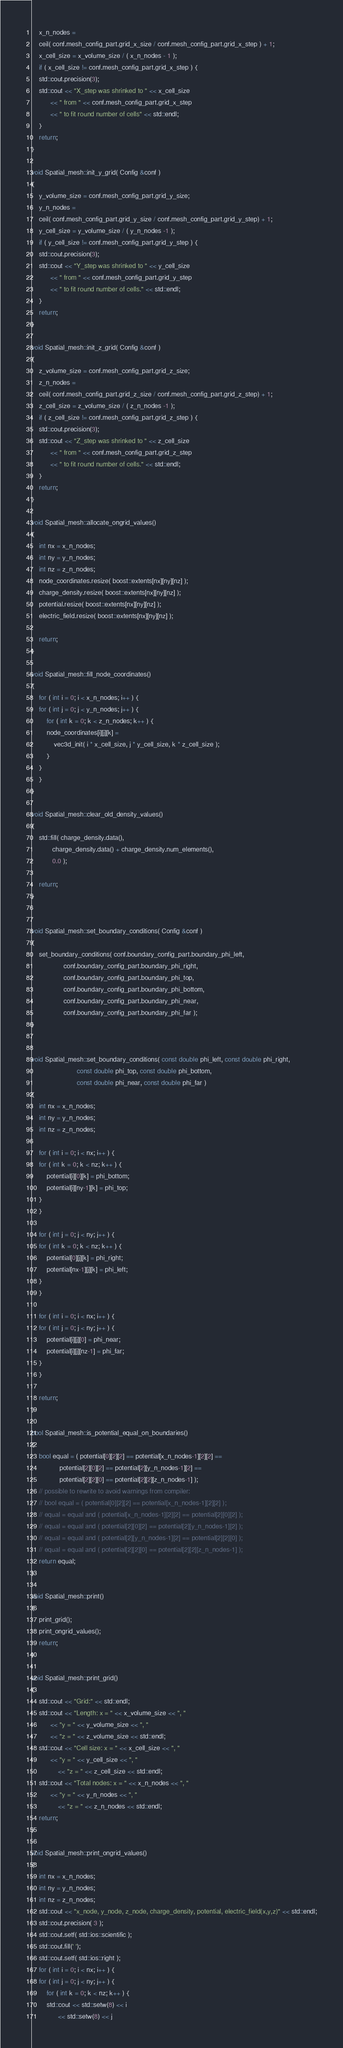Convert code to text. <code><loc_0><loc_0><loc_500><loc_500><_C++_>    x_n_nodes = 
	ceil( conf.mesh_config_part.grid_x_size / conf.mesh_config_part.grid_x_step ) + 1;
    x_cell_size = x_volume_size / ( x_n_nodes - 1 );
    if ( x_cell_size != conf.mesh_config_part.grid_x_step ) {
	std::cout.precision(3);
	std::cout << "X_step was shrinked to " << x_cell_size 
		  << " from " << conf.mesh_config_part.grid_x_step 
		  << " to fit round number of cells" << std::endl;
    }    
    return;
}

void Spatial_mesh::init_y_grid( Config &conf )
{
    y_volume_size = conf.mesh_config_part.grid_y_size;
    y_n_nodes = 
	ceil( conf.mesh_config_part.grid_y_size / conf.mesh_config_part.grid_y_step) + 1;
    y_cell_size = y_volume_size / ( y_n_nodes -1 );
    if ( y_cell_size != conf.mesh_config_part.grid_y_step ) {
	std::cout.precision(3);
	std::cout << "Y_step was shrinked to " << y_cell_size 
		  << " from " << conf.mesh_config_part.grid_y_step 
		  << " to fit round number of cells." << std::endl;
    }    
    return;
}

void Spatial_mesh::init_z_grid( Config &conf )
{
    z_volume_size = conf.mesh_config_part.grid_z_size;
    z_n_nodes = 
	ceil( conf.mesh_config_part.grid_z_size / conf.mesh_config_part.grid_z_step) + 1;
    z_cell_size = z_volume_size / ( z_n_nodes -1 );
    if ( z_cell_size != conf.mesh_config_part.grid_z_step ) {
	std::cout.precision(3);
	std::cout << "Z_step was shrinked to " << z_cell_size 
		  << " from " << conf.mesh_config_part.grid_z_step 
		  << " to fit round number of cells." << std::endl;
    }    
    return;
}

void Spatial_mesh::allocate_ongrid_values()
{
    int nx = x_n_nodes;
    int ny = y_n_nodes;
    int nz = z_n_nodes;
    node_coordinates.resize( boost::extents[nx][ny][nz] );
    charge_density.resize( boost::extents[nx][ny][nz] );
    potential.resize( boost::extents[nx][ny][nz] );
    electric_field.resize( boost::extents[nx][ny][nz] );

    return;
}

void Spatial_mesh::fill_node_coordinates()
{
    for ( int i = 0; i < x_n_nodes; i++ ) {
	for ( int j = 0; j < y_n_nodes; j++ ) {
	    for ( int k = 0; k < z_n_nodes; k++ ) {
		node_coordinates[i][j][k] =
		    vec3d_init( i * x_cell_size, j * y_cell_size, k * z_cell_size );
	    }
	}
    }
}

void Spatial_mesh::clear_old_density_values()
{
    std::fill( charge_density.data(),
	       charge_density.data() + charge_density.num_elements(),
	       0.0 );

    return;
}


void Spatial_mesh::set_boundary_conditions( Config &conf )
{
    set_boundary_conditions( conf.boundary_config_part.boundary_phi_left, 
			     conf.boundary_config_part.boundary_phi_right,
			     conf.boundary_config_part.boundary_phi_top, 
			     conf.boundary_config_part.boundary_phi_bottom,
			     conf.boundary_config_part.boundary_phi_near, 
			     conf.boundary_config_part.boundary_phi_far );
}


void Spatial_mesh::set_boundary_conditions( const double phi_left, const double phi_right,
					    const double phi_top, const double phi_bottom,
					    const double phi_near, const double phi_far )
{
    int nx = x_n_nodes;
    int ny = y_n_nodes;
    int nz = z_n_nodes;    	

    for ( int i = 0; i < nx; i++ ) {
	for ( int k = 0; k < nz; k++ ) {
	    potential[i][0][k] = phi_bottom;
	    potential[i][ny-1][k] = phi_top;
	}
    }
    
    for ( int j = 0; j < ny; j++ ) {
	for ( int k = 0; k < nz; k++ ) {
	    potential[0][j][k] = phi_right;
	    potential[nx-1][j][k] = phi_left;
	}
    }

    for ( int i = 0; i < nx; i++ ) {
	for ( int j = 0; j < ny; j++ ) {
	    potential[i][j][0] = phi_near;
	    potential[i][j][nz-1] = phi_far;
	}
    }

    return;
}

bool Spatial_mesh::is_potential_equal_on_boundaries()
{
    bool equal = ( potential[0][2][2] == potential[x_n_nodes-1][2][2] ==
    		   potential[2][0][2] == potential[2][y_n_nodes-1][2] ==
    		   potential[2][2][0] == potential[2][2][z_n_nodes-1] );
    // possible to rewrite to avoid warnings from compiler:
    // bool equal = ( potential[0][2][2] == potential[x_n_nodes-1][2][2] );
    // equal = equal and ( potential[x_n_nodes-1][2][2] == potential[2][0][2] );
    // equal = equal and ( potential[2][0][2] == potential[2][y_n_nodes-1][2] );
    // equal = equal and ( potential[2][y_n_nodes-1][2] == potential[2][2][0] );
    // equal = equal and ( potential[2][2][0] == potential[2][2][z_n_nodes-1] );
    return equal;
}

void Spatial_mesh::print()
{
    print_grid();
    print_ongrid_values();
    return;
}

void Spatial_mesh::print_grid()
{
    std::cout << "Grid:" << std::endl;
    std::cout << "Length: x = " << x_volume_size << ", "
	      << "y = " << y_volume_size << ", "
	      << "z = " << z_volume_size << std::endl;
    std::cout << "Cell size: x = " << x_cell_size << ", "
	      << "y = " << y_cell_size << ", "
    	      << "z = " << z_cell_size << std::endl;
    std::cout << "Total nodes: x = " << x_n_nodes << ", "
	      << "y = " << y_n_nodes << ", "
    	      << "z = " << z_n_nodes << std::endl;
    return;
}

void Spatial_mesh::print_ongrid_values()
{
    int nx = x_n_nodes;
    int ny = y_n_nodes;
    int nz = z_n_nodes;
    std::cout << "x_node, y_node, z_node, charge_density, potential, electric_field(x,y,z)" << std::endl;
    std::cout.precision( 3 );
    std::cout.setf( std::ios::scientific );
    std::cout.fill(' ');
    std::cout.setf( std::ios::right );
    for ( int i = 0; i < nx; i++ ) {
	for ( int j = 0; j < ny; j++ ) {
	    for ( int k = 0; k < nz; k++ ) {
		std::cout << std::setw(8) << i 
			  << std::setw(8) << j</code> 